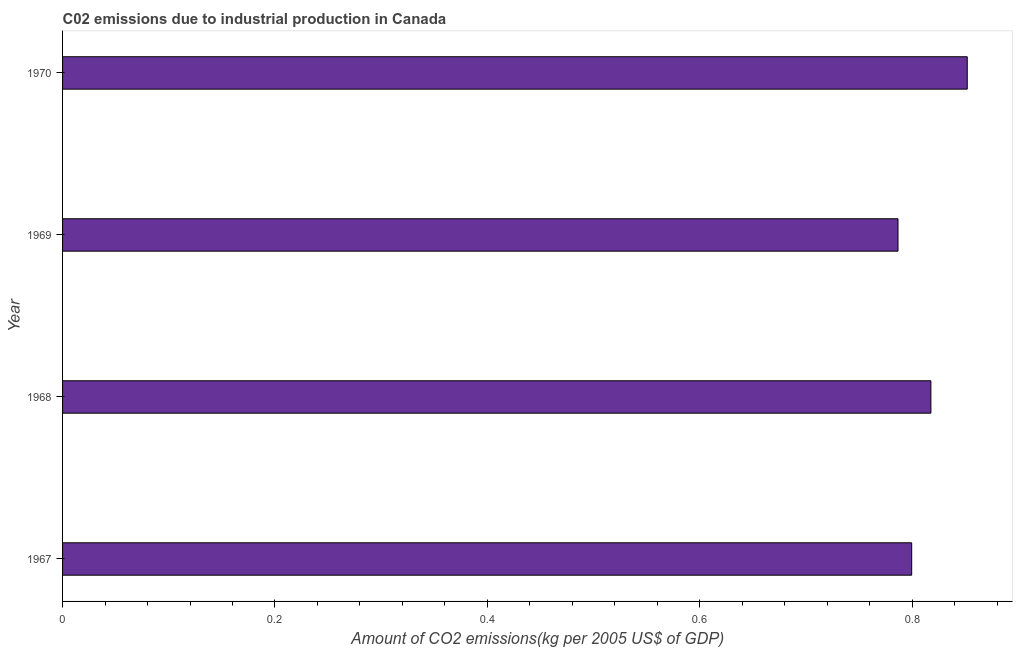What is the title of the graph?
Offer a very short reply. C02 emissions due to industrial production in Canada. What is the label or title of the X-axis?
Provide a succinct answer. Amount of CO2 emissions(kg per 2005 US$ of GDP). What is the amount of co2 emissions in 1968?
Your answer should be very brief. 0.82. Across all years, what is the maximum amount of co2 emissions?
Ensure brevity in your answer.  0.85. Across all years, what is the minimum amount of co2 emissions?
Your answer should be very brief. 0.79. In which year was the amount of co2 emissions maximum?
Your answer should be compact. 1970. In which year was the amount of co2 emissions minimum?
Give a very brief answer. 1969. What is the sum of the amount of co2 emissions?
Your response must be concise. 3.26. What is the difference between the amount of co2 emissions in 1967 and 1968?
Your response must be concise. -0.02. What is the average amount of co2 emissions per year?
Your answer should be compact. 0.81. What is the median amount of co2 emissions?
Your response must be concise. 0.81. What is the ratio of the amount of co2 emissions in 1968 to that in 1969?
Offer a very short reply. 1.04. Is the difference between the amount of co2 emissions in 1969 and 1970 greater than the difference between any two years?
Provide a short and direct response. Yes. What is the difference between the highest and the second highest amount of co2 emissions?
Provide a short and direct response. 0.03. What is the difference between the highest and the lowest amount of co2 emissions?
Your answer should be very brief. 0.07. In how many years, is the amount of co2 emissions greater than the average amount of co2 emissions taken over all years?
Provide a succinct answer. 2. Are all the bars in the graph horizontal?
Keep it short and to the point. Yes. How many years are there in the graph?
Ensure brevity in your answer.  4. What is the difference between two consecutive major ticks on the X-axis?
Make the answer very short. 0.2. Are the values on the major ticks of X-axis written in scientific E-notation?
Your response must be concise. No. What is the Amount of CO2 emissions(kg per 2005 US$ of GDP) in 1967?
Provide a succinct answer. 0.8. What is the Amount of CO2 emissions(kg per 2005 US$ of GDP) of 1968?
Offer a terse response. 0.82. What is the Amount of CO2 emissions(kg per 2005 US$ of GDP) of 1969?
Give a very brief answer. 0.79. What is the Amount of CO2 emissions(kg per 2005 US$ of GDP) of 1970?
Your response must be concise. 0.85. What is the difference between the Amount of CO2 emissions(kg per 2005 US$ of GDP) in 1967 and 1968?
Make the answer very short. -0.02. What is the difference between the Amount of CO2 emissions(kg per 2005 US$ of GDP) in 1967 and 1969?
Provide a short and direct response. 0.01. What is the difference between the Amount of CO2 emissions(kg per 2005 US$ of GDP) in 1967 and 1970?
Your answer should be very brief. -0.05. What is the difference between the Amount of CO2 emissions(kg per 2005 US$ of GDP) in 1968 and 1969?
Your response must be concise. 0.03. What is the difference between the Amount of CO2 emissions(kg per 2005 US$ of GDP) in 1968 and 1970?
Keep it short and to the point. -0.03. What is the difference between the Amount of CO2 emissions(kg per 2005 US$ of GDP) in 1969 and 1970?
Your answer should be very brief. -0.07. What is the ratio of the Amount of CO2 emissions(kg per 2005 US$ of GDP) in 1967 to that in 1970?
Keep it short and to the point. 0.94. What is the ratio of the Amount of CO2 emissions(kg per 2005 US$ of GDP) in 1968 to that in 1969?
Your response must be concise. 1.04. What is the ratio of the Amount of CO2 emissions(kg per 2005 US$ of GDP) in 1969 to that in 1970?
Make the answer very short. 0.92. 